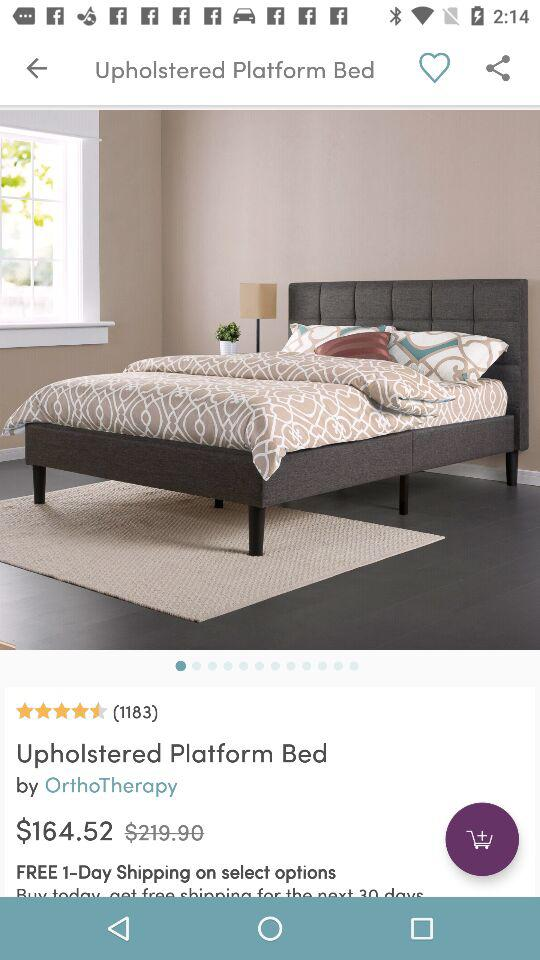Who is the maker of the bed? The maker of the bed is "OrthoTherapy". 